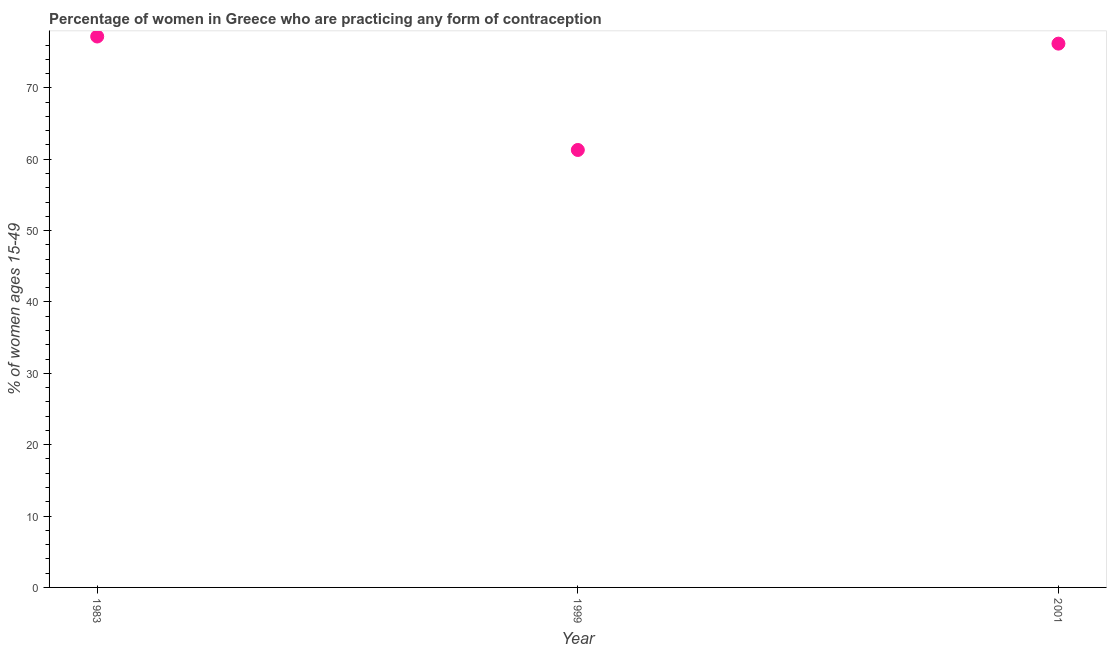What is the contraceptive prevalence in 1999?
Provide a short and direct response. 61.3. Across all years, what is the maximum contraceptive prevalence?
Give a very brief answer. 77.2. Across all years, what is the minimum contraceptive prevalence?
Offer a very short reply. 61.3. In which year was the contraceptive prevalence minimum?
Your answer should be compact. 1999. What is the sum of the contraceptive prevalence?
Your answer should be very brief. 214.7. What is the difference between the contraceptive prevalence in 1983 and 1999?
Ensure brevity in your answer.  15.9. What is the average contraceptive prevalence per year?
Your answer should be compact. 71.57. What is the median contraceptive prevalence?
Keep it short and to the point. 76.2. In how many years, is the contraceptive prevalence greater than 64 %?
Offer a terse response. 2. What is the ratio of the contraceptive prevalence in 1983 to that in 1999?
Your response must be concise. 1.26. Is the difference between the contraceptive prevalence in 1983 and 2001 greater than the difference between any two years?
Give a very brief answer. No. What is the difference between the highest and the lowest contraceptive prevalence?
Give a very brief answer. 15.9. In how many years, is the contraceptive prevalence greater than the average contraceptive prevalence taken over all years?
Provide a short and direct response. 2. How many dotlines are there?
Ensure brevity in your answer.  1. How many years are there in the graph?
Provide a short and direct response. 3. What is the difference between two consecutive major ticks on the Y-axis?
Offer a very short reply. 10. Are the values on the major ticks of Y-axis written in scientific E-notation?
Your answer should be very brief. No. Does the graph contain grids?
Your answer should be very brief. No. What is the title of the graph?
Keep it short and to the point. Percentage of women in Greece who are practicing any form of contraception. What is the label or title of the Y-axis?
Provide a short and direct response. % of women ages 15-49. What is the % of women ages 15-49 in 1983?
Ensure brevity in your answer.  77.2. What is the % of women ages 15-49 in 1999?
Ensure brevity in your answer.  61.3. What is the % of women ages 15-49 in 2001?
Your answer should be compact. 76.2. What is the difference between the % of women ages 15-49 in 1983 and 2001?
Your response must be concise. 1. What is the difference between the % of women ages 15-49 in 1999 and 2001?
Provide a succinct answer. -14.9. What is the ratio of the % of women ages 15-49 in 1983 to that in 1999?
Offer a very short reply. 1.26. What is the ratio of the % of women ages 15-49 in 1999 to that in 2001?
Your answer should be very brief. 0.8. 